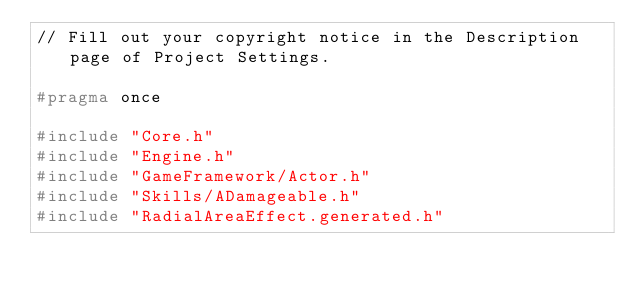Convert code to text. <code><loc_0><loc_0><loc_500><loc_500><_C_>// Fill out your copyright notice in the Description page of Project Settings.

#pragma once

#include "Core.h"
#include "Engine.h"
#include "GameFramework/Actor.h"
#include "Skills/ADamageable.h"
#include "RadialAreaEffect.generated.h"
</code> 